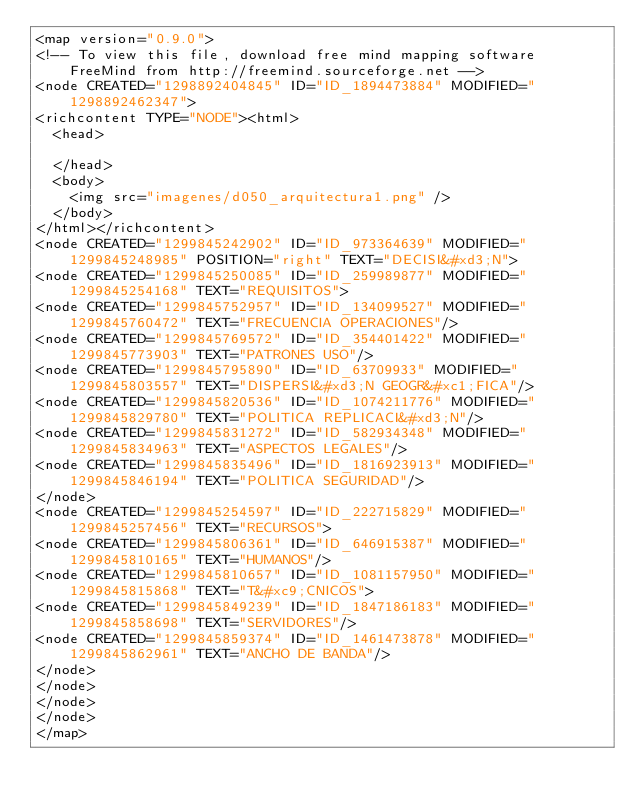<code> <loc_0><loc_0><loc_500><loc_500><_ObjectiveC_><map version="0.9.0">
<!-- To view this file, download free mind mapping software FreeMind from http://freemind.sourceforge.net -->
<node CREATED="1298892404845" ID="ID_1894473884" MODIFIED="1298892462347">
<richcontent TYPE="NODE"><html>
  <head>
    
  </head>
  <body>
    <img src="imagenes/d050_arquitectura1.png" />
  </body>
</html></richcontent>
<node CREATED="1299845242902" ID="ID_973364639" MODIFIED="1299845248985" POSITION="right" TEXT="DECISI&#xd3;N">
<node CREATED="1299845250085" ID="ID_259989877" MODIFIED="1299845254168" TEXT="REQUISITOS">
<node CREATED="1299845752957" ID="ID_134099527" MODIFIED="1299845760472" TEXT="FRECUENCIA OPERACIONES"/>
<node CREATED="1299845769572" ID="ID_354401422" MODIFIED="1299845773903" TEXT="PATRONES USO"/>
<node CREATED="1299845795890" ID="ID_63709933" MODIFIED="1299845803557" TEXT="DISPERSI&#xd3;N GEOGR&#xc1;FICA"/>
<node CREATED="1299845820536" ID="ID_1074211776" MODIFIED="1299845829780" TEXT="POLITICA REPLICACI&#xd3;N"/>
<node CREATED="1299845831272" ID="ID_582934348" MODIFIED="1299845834963" TEXT="ASPECTOS LEGALES"/>
<node CREATED="1299845835496" ID="ID_1816923913" MODIFIED="1299845846194" TEXT="POLITICA SEGURIDAD"/>
</node>
<node CREATED="1299845254597" ID="ID_222715829" MODIFIED="1299845257456" TEXT="RECURSOS">
<node CREATED="1299845806361" ID="ID_646915387" MODIFIED="1299845810165" TEXT="HUMANOS"/>
<node CREATED="1299845810657" ID="ID_1081157950" MODIFIED="1299845815868" TEXT="T&#xc9;CNICOS">
<node CREATED="1299845849239" ID="ID_1847186183" MODIFIED="1299845858698" TEXT="SERVIDORES"/>
<node CREATED="1299845859374" ID="ID_1461473878" MODIFIED="1299845862961" TEXT="ANCHO DE BANDA"/>
</node>
</node>
</node>
</node>
</map>
</code> 